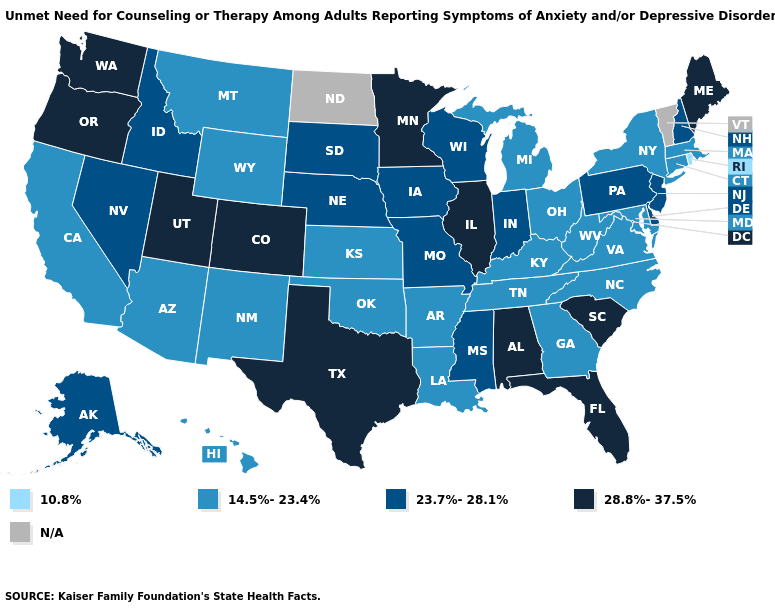What is the highest value in the Northeast ?
Quick response, please. 28.8%-37.5%. What is the highest value in the USA?
Short answer required. 28.8%-37.5%. Name the states that have a value in the range 10.8%?
Write a very short answer. Rhode Island. Does the first symbol in the legend represent the smallest category?
Be succinct. Yes. Does Montana have the highest value in the West?
Be succinct. No. What is the value of Arkansas?
Write a very short answer. 14.5%-23.4%. What is the value of New York?
Quick response, please. 14.5%-23.4%. How many symbols are there in the legend?
Be succinct. 5. Does the map have missing data?
Keep it brief. Yes. Does the map have missing data?
Give a very brief answer. Yes. Among the states that border Florida , does Georgia have the lowest value?
Concise answer only. Yes. What is the lowest value in the MidWest?
Write a very short answer. 14.5%-23.4%. What is the value of Wisconsin?
Answer briefly. 23.7%-28.1%. What is the value of Colorado?
Be succinct. 28.8%-37.5%. 